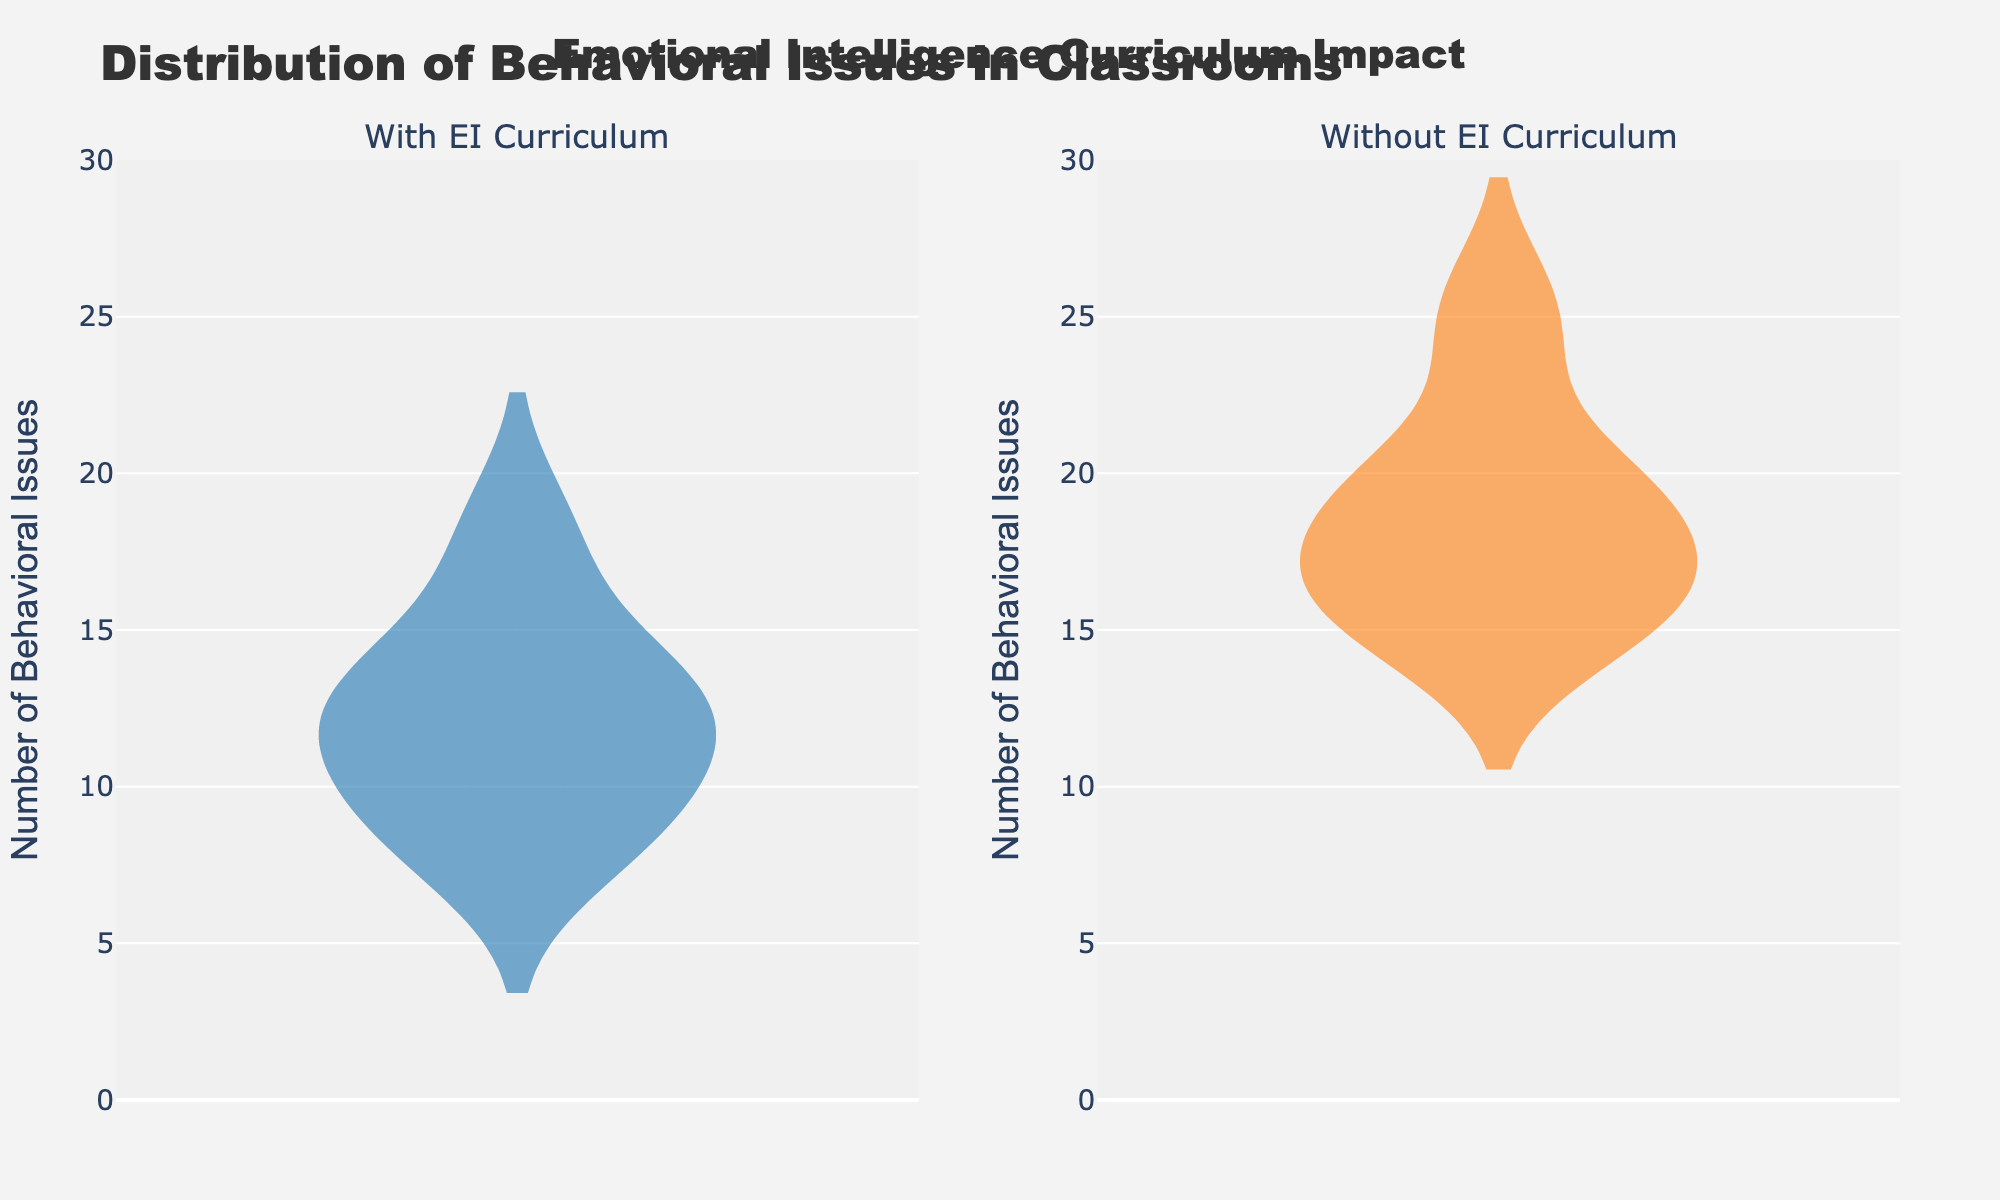What is the title of the figure? The title is displayed at the top center of the figure and reads "Distribution of Behavioral Issues in Classrooms".
Answer: Distribution of Behavioral Issues in Classrooms Which subplot uses orange color for its density plot? The subplot on the right uses orange color for its density plot, representing classrooms without an Emotional Intelligence (EI) curriculum.
Answer: Without EI Curriculum How many subplots are there in the figure? There are two subplots in the figure, one for classrooms with EI curriculum and one for classrooms without EI curriculum.
Answer: Two What is the range of the y-axis in both subplots? The y-axis range is labeled from 0 to 30, indicating it captures the number of behavioral issues reported.
Answer: 0 to 30 Which group, "With EI Curriculum" or "Without EI Curriculum", has a higher median number of behavioral issues? The median can be inferred from the box plot within each violin plot. The "Without EI Curriculum" group has a higher median number of behavioral issues compared to the "With EI Curriculum" group.
Answer: Without EI Curriculum Compare the density plots: Which group shows a wider spread of behavioral issues? The "Without EI Curriculum" group's density plot shows a wider spread, indicating more variability in the number of behavioral issues. The "With EI Curriculum" group has a narrower spread.
Answer: Without EI Curriculum What appears to be the peak range of behavioral issues for classrooms with an EI curriculum? The density plot for "With EI Curriculum" is more concentrated around 8-14 behavioral issues, indicating this range has a higher density.
Answer: 8-14 In which group are extreme values (outliers) more likely to be found? Extreme values or outliers appear more frequently in the "Without EI Curriculum" group, evidenced by the longer tails in the density and the box plot.
Answer: Without EI Curriculum What is the number of behavioral issues in the densest part of the plot for classrooms without an EI curriculum? The densest part of the plot for "Without EI Curriculum" appears around 15-20 behavioral issues.
Answer: 15-20 Which group likely has less variability and why? Greater spread or range in the density plot illustrates more variability. "With EI Curriculum" likely has less variability because its density plot is more concentrated and has a narrower spread.
Answer: With EI Curriculum 